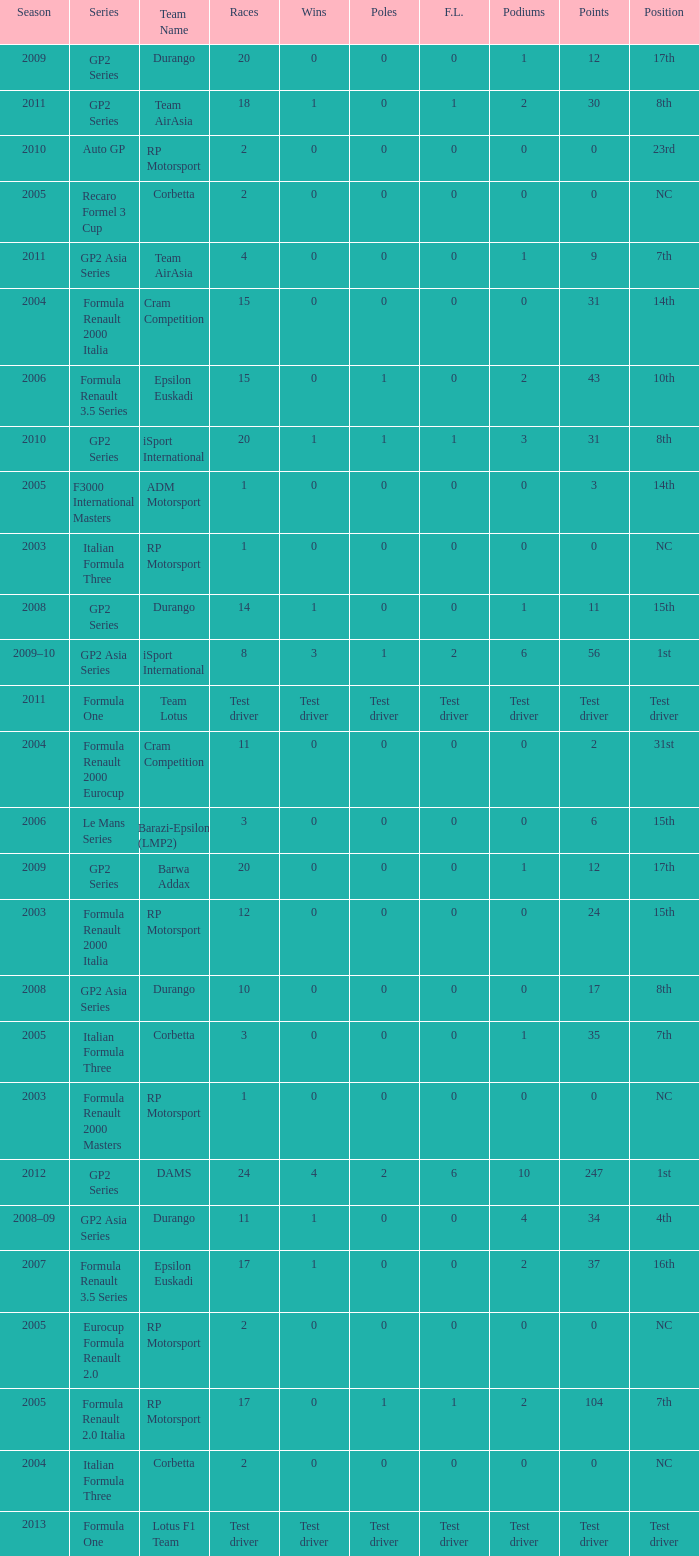What races have gp2 series, 0 F.L. and a 17th position? 20, 20. 